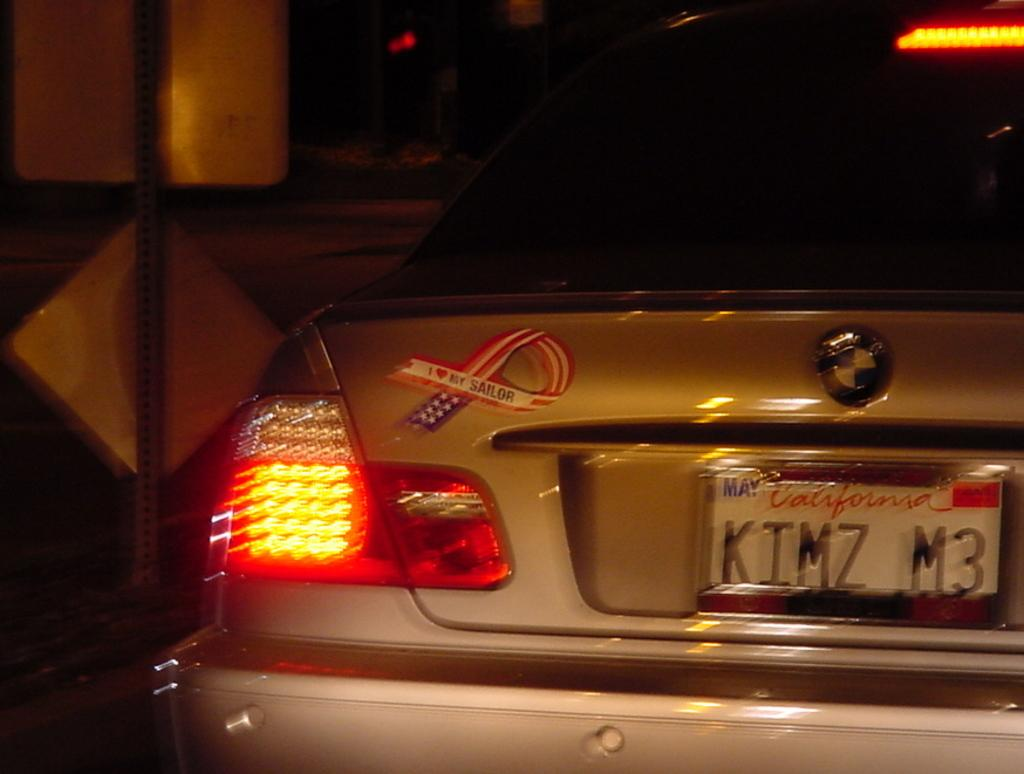<image>
Write a terse but informative summary of the picture. car with california tags and a i heart my sailor sticker 